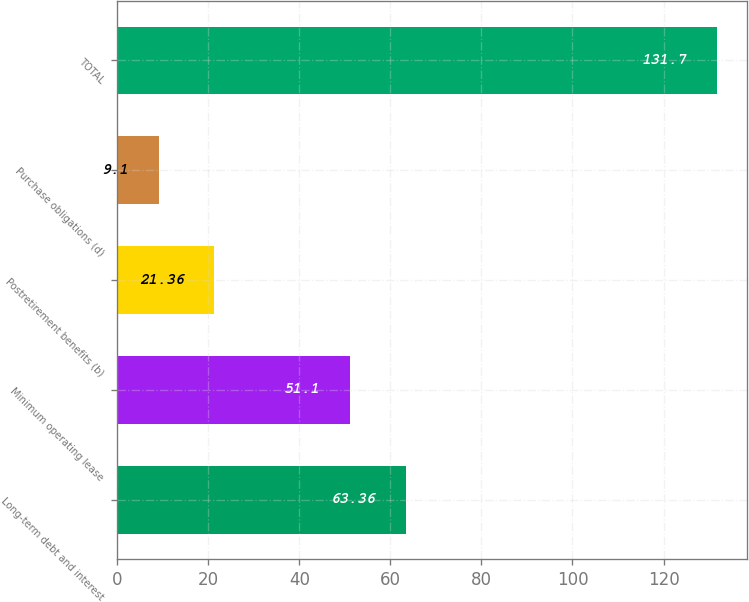Convert chart. <chart><loc_0><loc_0><loc_500><loc_500><bar_chart><fcel>Long-term debt and interest<fcel>Minimum operating lease<fcel>Postretirement benefits (b)<fcel>Purchase obligations (d)<fcel>TOTAL<nl><fcel>63.36<fcel>51.1<fcel>21.36<fcel>9.1<fcel>131.7<nl></chart> 